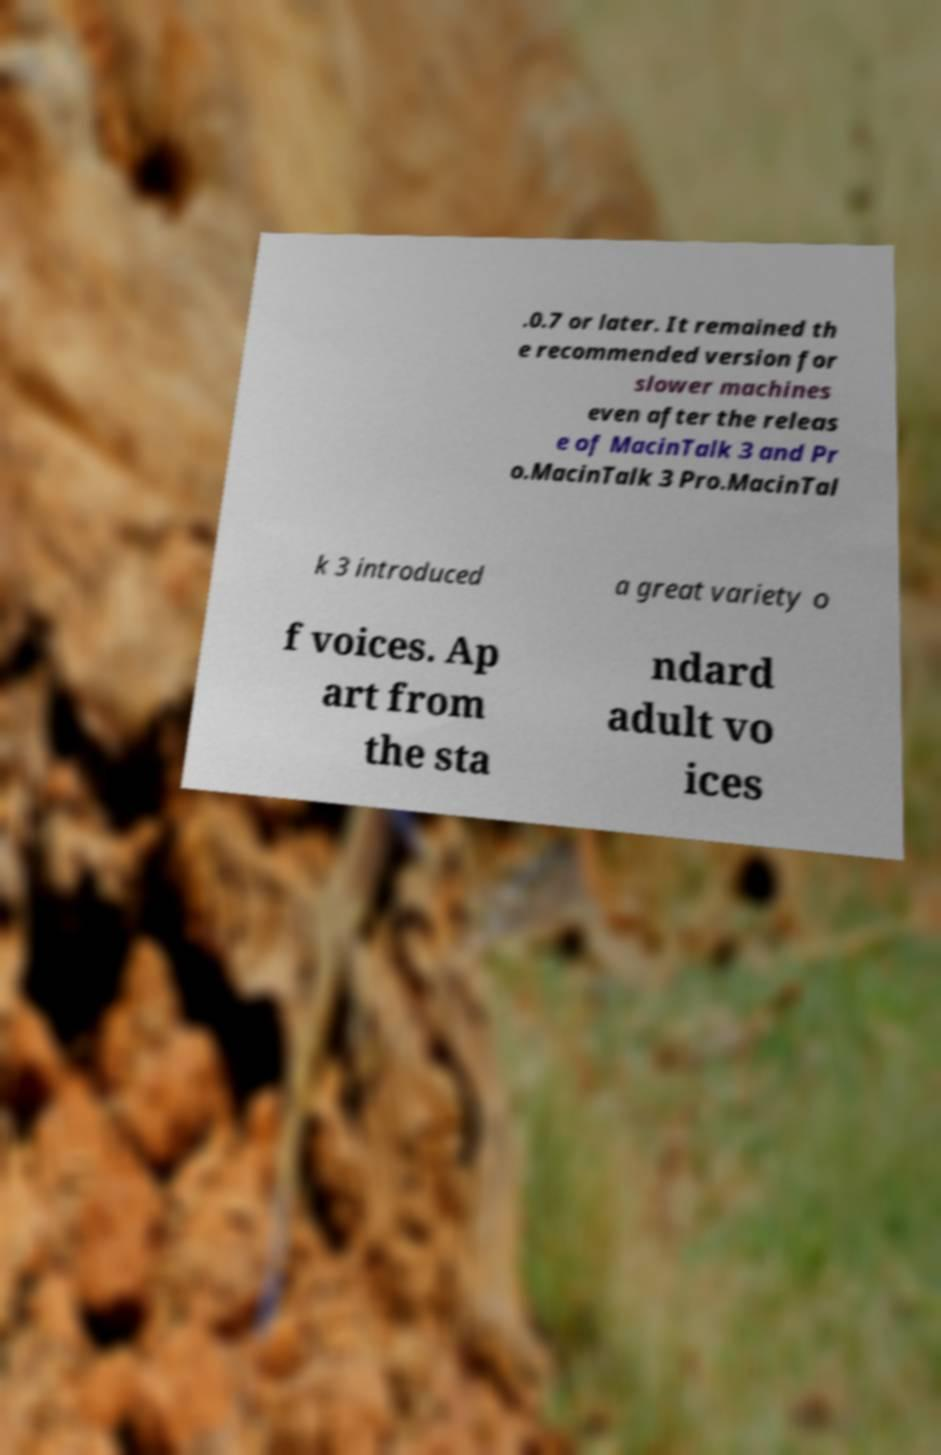What messages or text are displayed in this image? I need them in a readable, typed format. .0.7 or later. It remained th e recommended version for slower machines even after the releas e of MacinTalk 3 and Pr o.MacinTalk 3 Pro.MacinTal k 3 introduced a great variety o f voices. Ap art from the sta ndard adult vo ices 